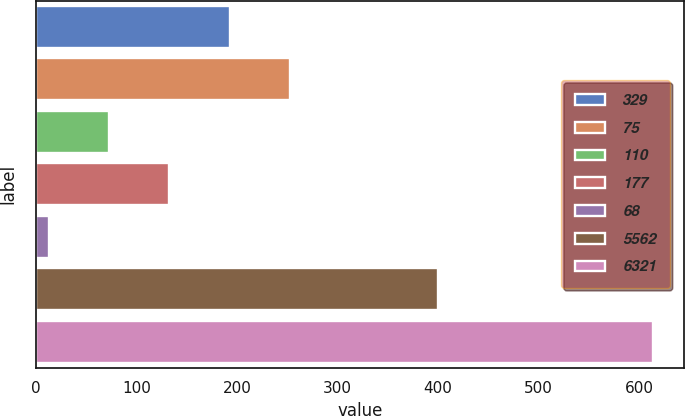Convert chart to OTSL. <chart><loc_0><loc_0><loc_500><loc_500><bar_chart><fcel>329<fcel>75<fcel>110<fcel>177<fcel>68<fcel>5562<fcel>6321<nl><fcel>192.82<fcel>252.96<fcel>72.54<fcel>132.68<fcel>12.4<fcel>400.4<fcel>613.8<nl></chart> 